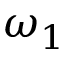Convert formula to latex. <formula><loc_0><loc_0><loc_500><loc_500>\omega _ { 1 }</formula> 